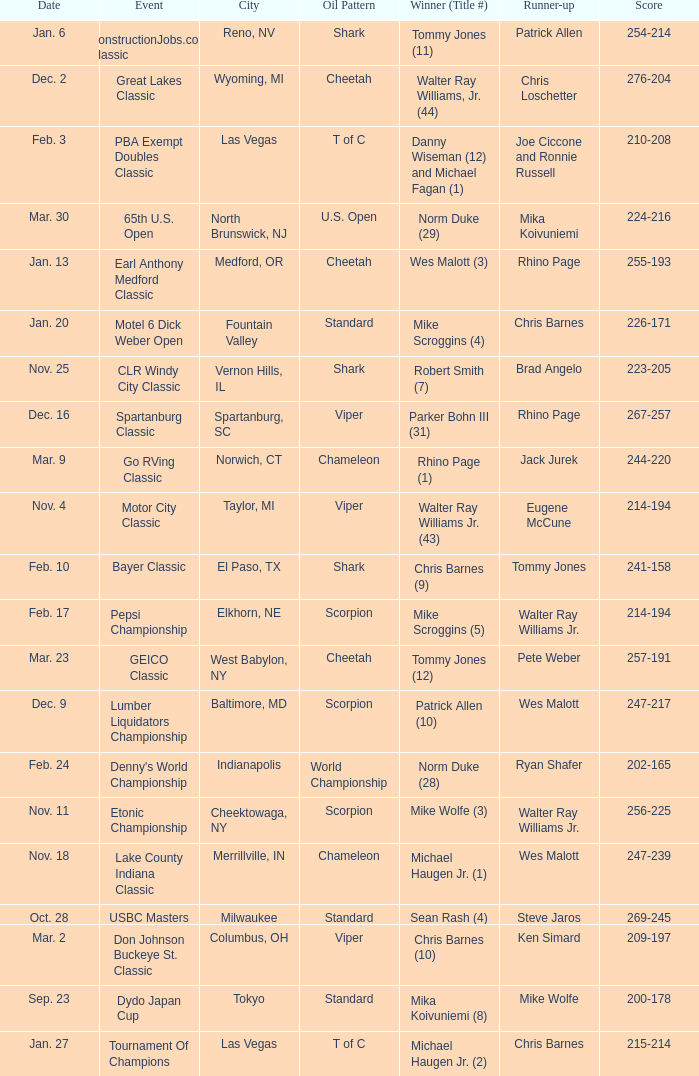Name the Event which has a Winner (Title #) of parker bohn iii (31)? Spartanburg Classic. 